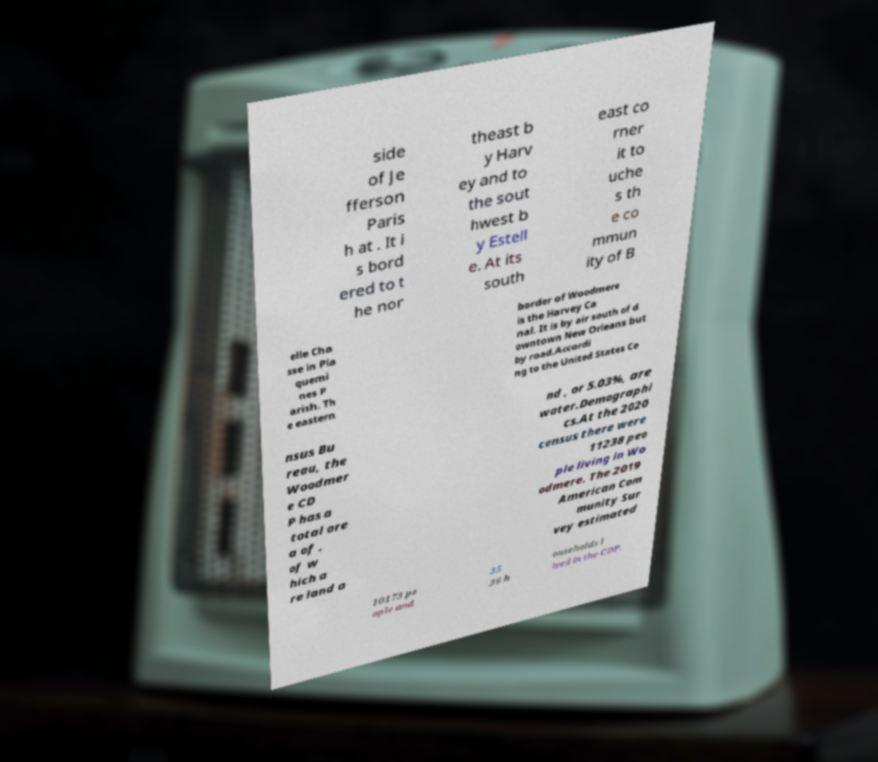Can you read and provide the text displayed in the image?This photo seems to have some interesting text. Can you extract and type it out for me? side of Je fferson Paris h at . It i s bord ered to t he nor theast b y Harv ey and to the sout hwest b y Estell e. At its south east co rner it to uche s th e co mmun ity of B elle Cha sse in Pla quemi nes P arish. Th e eastern border of Woodmere is the Harvey Ca nal. It is by air south of d owntown New Orleans but by road.Accordi ng to the United States Ce nsus Bu reau, the Woodmer e CD P has a total are a of , of w hich a re land a nd , or 5.03%, are water.Demographi cs.At the 2020 census there were 11238 peo ple living in Wo odmere. The 2019 American Com munity Sur vey estimated 10173 pe ople and 35 36 h ouseholds l ived in the CDP. 